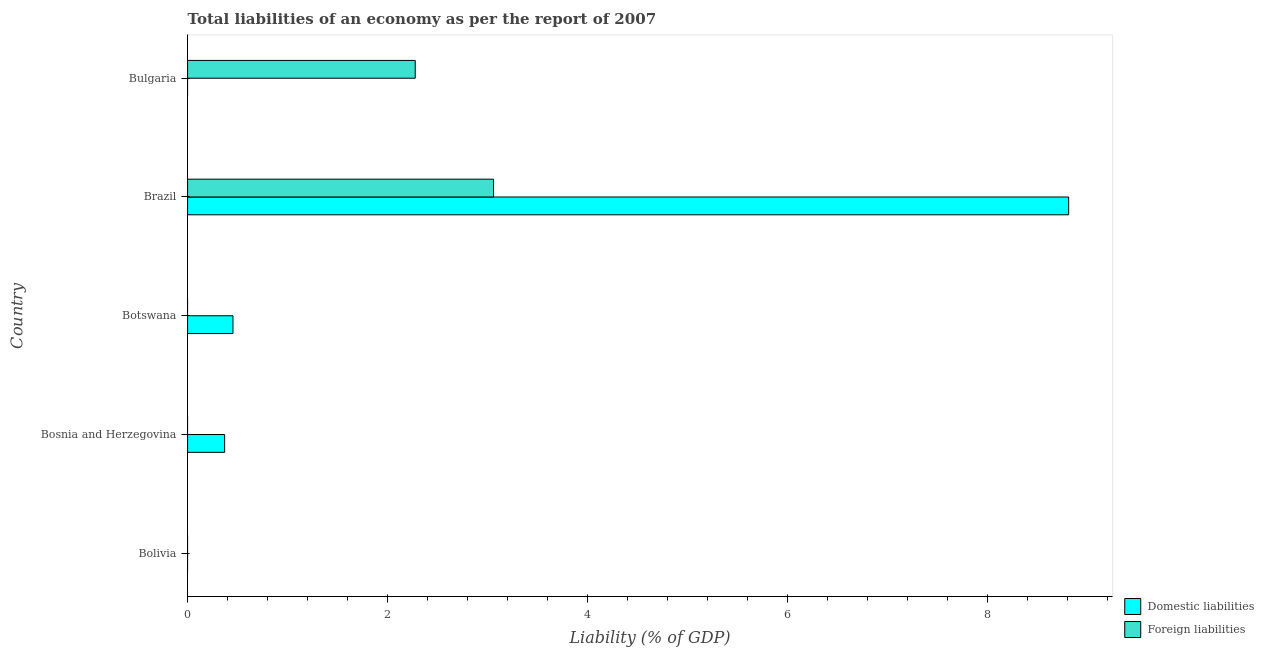What is the label of the 1st group of bars from the top?
Your answer should be compact. Bulgaria. In how many cases, is the number of bars for a given country not equal to the number of legend labels?
Provide a succinct answer. 4. What is the incurrence of foreign liabilities in Brazil?
Make the answer very short. 3.06. Across all countries, what is the maximum incurrence of foreign liabilities?
Ensure brevity in your answer.  3.06. Across all countries, what is the minimum incurrence of domestic liabilities?
Keep it short and to the point. 0. What is the total incurrence of domestic liabilities in the graph?
Your answer should be very brief. 9.64. What is the difference between the incurrence of domestic liabilities in Bosnia and Herzegovina and that in Brazil?
Your response must be concise. -8.44. What is the difference between the incurrence of foreign liabilities in Bulgaria and the incurrence of domestic liabilities in Bolivia?
Ensure brevity in your answer.  2.28. What is the average incurrence of domestic liabilities per country?
Provide a short and direct response. 1.93. What is the difference between the incurrence of domestic liabilities and incurrence of foreign liabilities in Brazil?
Give a very brief answer. 5.75. What is the ratio of the incurrence of domestic liabilities in Botswana to that in Brazil?
Keep it short and to the point. 0.05. Is the incurrence of domestic liabilities in Bosnia and Herzegovina less than that in Botswana?
Make the answer very short. Yes. What is the difference between the highest and the second highest incurrence of domestic liabilities?
Provide a short and direct response. 8.36. What is the difference between the highest and the lowest incurrence of domestic liabilities?
Give a very brief answer. 8.81. Is the sum of the incurrence of domestic liabilities in Bosnia and Herzegovina and Brazil greater than the maximum incurrence of foreign liabilities across all countries?
Your response must be concise. Yes. How many bars are there?
Provide a short and direct response. 5. Are all the bars in the graph horizontal?
Your answer should be compact. Yes. What is the difference between two consecutive major ticks on the X-axis?
Offer a terse response. 2. Are the values on the major ticks of X-axis written in scientific E-notation?
Give a very brief answer. No. Where does the legend appear in the graph?
Your response must be concise. Bottom right. How many legend labels are there?
Make the answer very short. 2. How are the legend labels stacked?
Keep it short and to the point. Vertical. What is the title of the graph?
Provide a short and direct response. Total liabilities of an economy as per the report of 2007. Does "current US$" appear as one of the legend labels in the graph?
Offer a terse response. No. What is the label or title of the X-axis?
Ensure brevity in your answer.  Liability (% of GDP). What is the Liability (% of GDP) of Domestic liabilities in Bolivia?
Provide a short and direct response. 0. What is the Liability (% of GDP) of Foreign liabilities in Bolivia?
Offer a very short reply. 0. What is the Liability (% of GDP) in Domestic liabilities in Bosnia and Herzegovina?
Your response must be concise. 0.37. What is the Liability (% of GDP) in Domestic liabilities in Botswana?
Offer a terse response. 0.45. What is the Liability (% of GDP) in Foreign liabilities in Botswana?
Offer a very short reply. 0. What is the Liability (% of GDP) in Domestic liabilities in Brazil?
Your answer should be compact. 8.81. What is the Liability (% of GDP) of Foreign liabilities in Brazil?
Give a very brief answer. 3.06. What is the Liability (% of GDP) in Foreign liabilities in Bulgaria?
Keep it short and to the point. 2.28. Across all countries, what is the maximum Liability (% of GDP) in Domestic liabilities?
Provide a succinct answer. 8.81. Across all countries, what is the maximum Liability (% of GDP) of Foreign liabilities?
Provide a short and direct response. 3.06. Across all countries, what is the minimum Liability (% of GDP) in Domestic liabilities?
Your answer should be compact. 0. What is the total Liability (% of GDP) of Domestic liabilities in the graph?
Ensure brevity in your answer.  9.64. What is the total Liability (% of GDP) of Foreign liabilities in the graph?
Your answer should be very brief. 5.34. What is the difference between the Liability (% of GDP) of Domestic liabilities in Bosnia and Herzegovina and that in Botswana?
Ensure brevity in your answer.  -0.08. What is the difference between the Liability (% of GDP) in Domestic liabilities in Bosnia and Herzegovina and that in Brazil?
Provide a short and direct response. -8.44. What is the difference between the Liability (% of GDP) in Domestic liabilities in Botswana and that in Brazil?
Offer a very short reply. -8.36. What is the difference between the Liability (% of GDP) in Foreign liabilities in Brazil and that in Bulgaria?
Offer a terse response. 0.78. What is the difference between the Liability (% of GDP) in Domestic liabilities in Bosnia and Herzegovina and the Liability (% of GDP) in Foreign liabilities in Brazil?
Your response must be concise. -2.69. What is the difference between the Liability (% of GDP) in Domestic liabilities in Bosnia and Herzegovina and the Liability (% of GDP) in Foreign liabilities in Bulgaria?
Ensure brevity in your answer.  -1.91. What is the difference between the Liability (% of GDP) in Domestic liabilities in Botswana and the Liability (% of GDP) in Foreign liabilities in Brazil?
Offer a terse response. -2.61. What is the difference between the Liability (% of GDP) of Domestic liabilities in Botswana and the Liability (% of GDP) of Foreign liabilities in Bulgaria?
Keep it short and to the point. -1.82. What is the difference between the Liability (% of GDP) in Domestic liabilities in Brazil and the Liability (% of GDP) in Foreign liabilities in Bulgaria?
Provide a short and direct response. 6.54. What is the average Liability (% of GDP) of Domestic liabilities per country?
Ensure brevity in your answer.  1.93. What is the average Liability (% of GDP) in Foreign liabilities per country?
Offer a very short reply. 1.07. What is the difference between the Liability (% of GDP) of Domestic liabilities and Liability (% of GDP) of Foreign liabilities in Brazil?
Offer a very short reply. 5.75. What is the ratio of the Liability (% of GDP) of Domestic liabilities in Bosnia and Herzegovina to that in Botswana?
Offer a very short reply. 0.82. What is the ratio of the Liability (% of GDP) of Domestic liabilities in Bosnia and Herzegovina to that in Brazil?
Provide a short and direct response. 0.04. What is the ratio of the Liability (% of GDP) of Domestic liabilities in Botswana to that in Brazil?
Offer a terse response. 0.05. What is the ratio of the Liability (% of GDP) in Foreign liabilities in Brazil to that in Bulgaria?
Your answer should be compact. 1.34. What is the difference between the highest and the second highest Liability (% of GDP) in Domestic liabilities?
Your response must be concise. 8.36. What is the difference between the highest and the lowest Liability (% of GDP) of Domestic liabilities?
Your answer should be compact. 8.81. What is the difference between the highest and the lowest Liability (% of GDP) of Foreign liabilities?
Give a very brief answer. 3.06. 